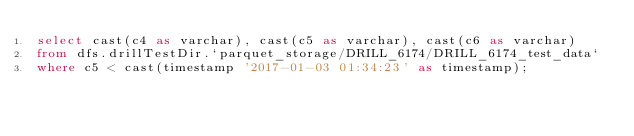Convert code to text. <code><loc_0><loc_0><loc_500><loc_500><_SQL_>select cast(c4 as varchar), cast(c5 as varchar), cast(c6 as varchar)
from dfs.drillTestDir.`parquet_storage/DRILL_6174/DRILL_6174_test_data`
where c5 < cast(timestamp '2017-01-03 01:34:23' as timestamp);</code> 